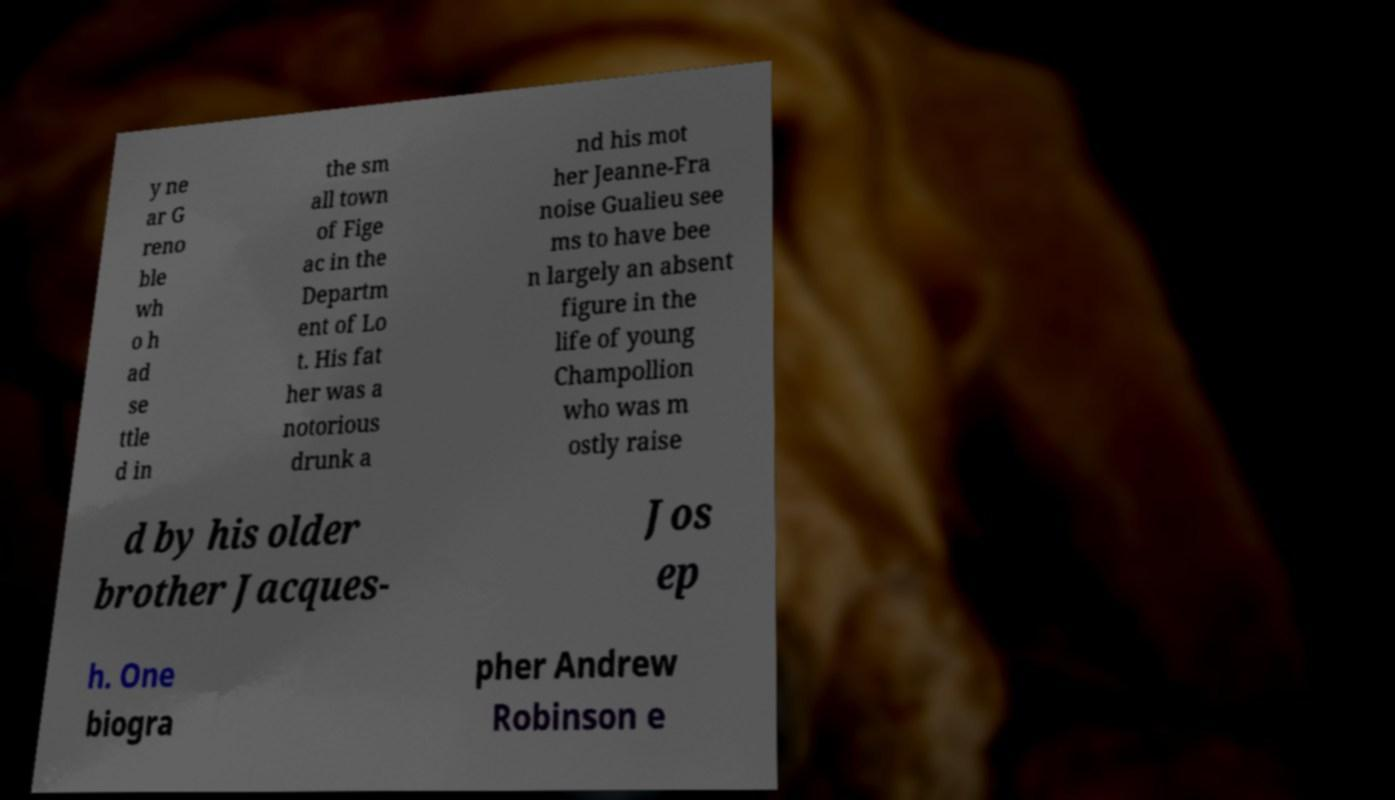Could you extract and type out the text from this image? y ne ar G reno ble wh o h ad se ttle d in the sm all town of Fige ac in the Departm ent of Lo t. His fat her was a notorious drunk a nd his mot her Jeanne-Fra noise Gualieu see ms to have bee n largely an absent figure in the life of young Champollion who was m ostly raise d by his older brother Jacques- Jos ep h. One biogra pher Andrew Robinson e 